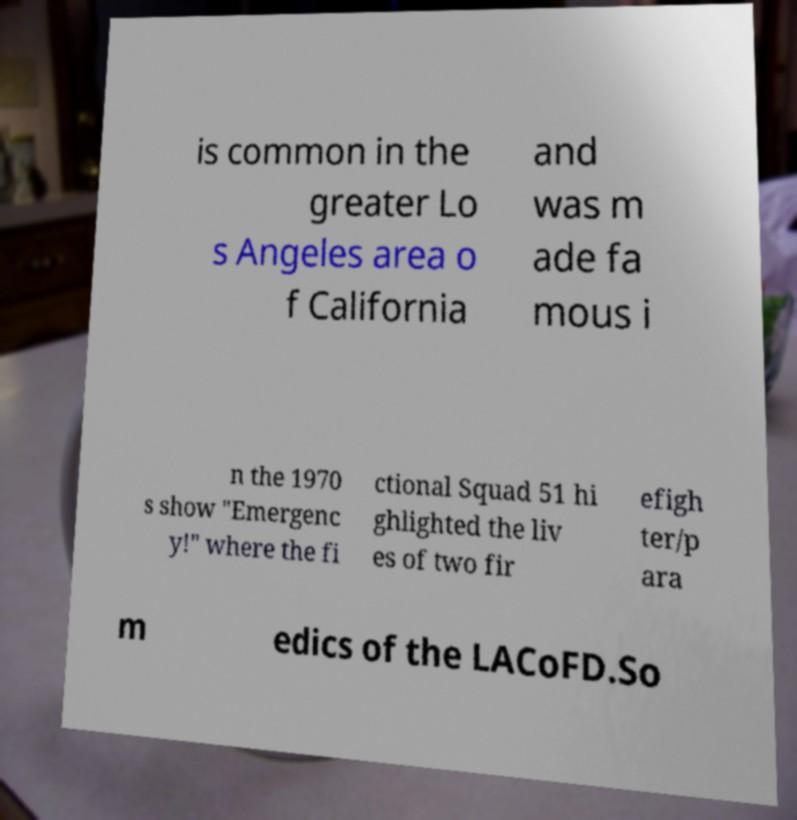For documentation purposes, I need the text within this image transcribed. Could you provide that? is common in the greater Lo s Angeles area o f California and was m ade fa mous i n the 1970 s show "Emergenc y!" where the fi ctional Squad 51 hi ghlighted the liv es of two fir efigh ter/p ara m edics of the LACoFD.So 